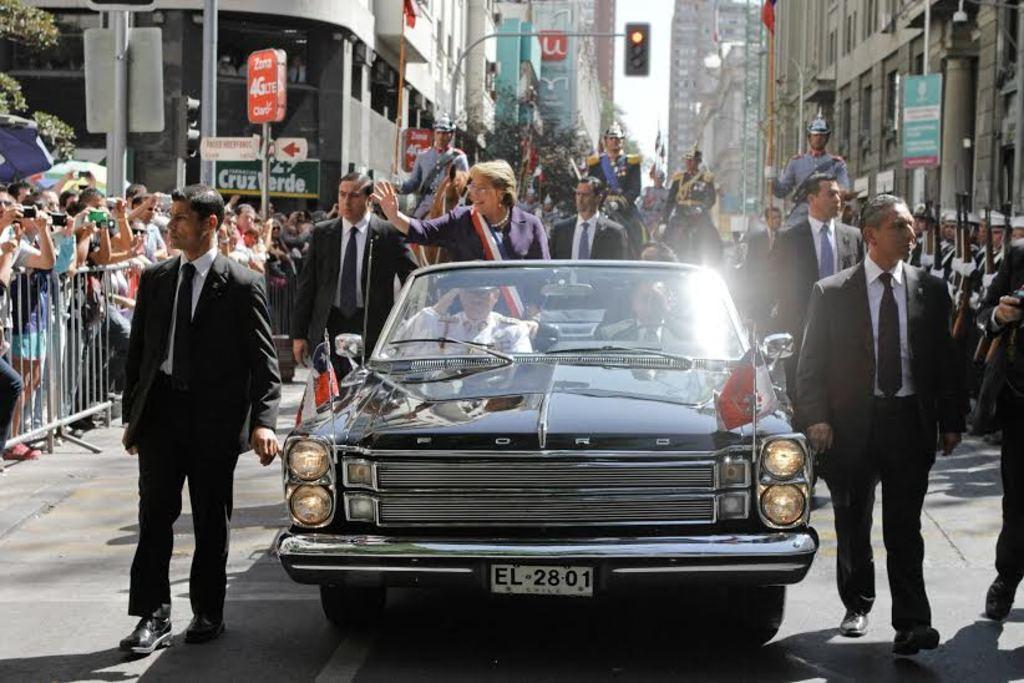Please provide a concise description of this image. In this picture we can see a vehicle and the two persons sitting inside it. We can see a women standing and all the persons wearing same attire standing near to the car. This is a traffic signal. This is a sky. Across the road we can see buildings. This is a flag. Behind to the fence we can see persons standing and taking snaps. 